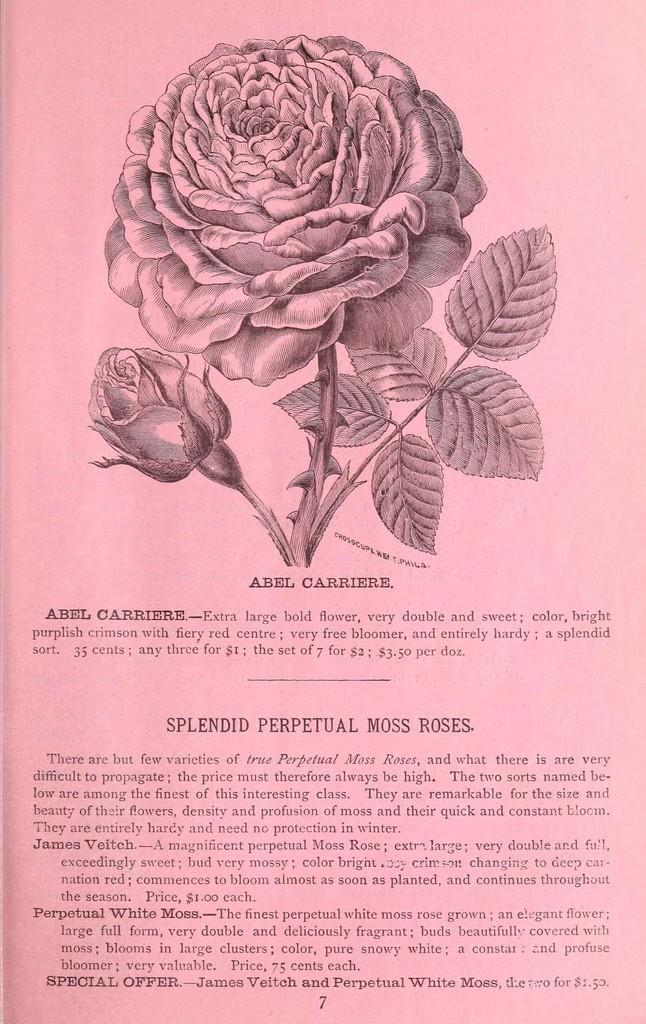What is written or drawn on the paper in the image? There is text on the paper in the image, along with an image of a stem with a flower and an image of a bush. What specific features can be seen in the images on the paper? The images on the paper include a stem with a flower, a bush, thorns, and leaves. What type of popcorn is being served at the event depicted in the image? There is no event or popcorn present in the image; it features text and images on a paper. 